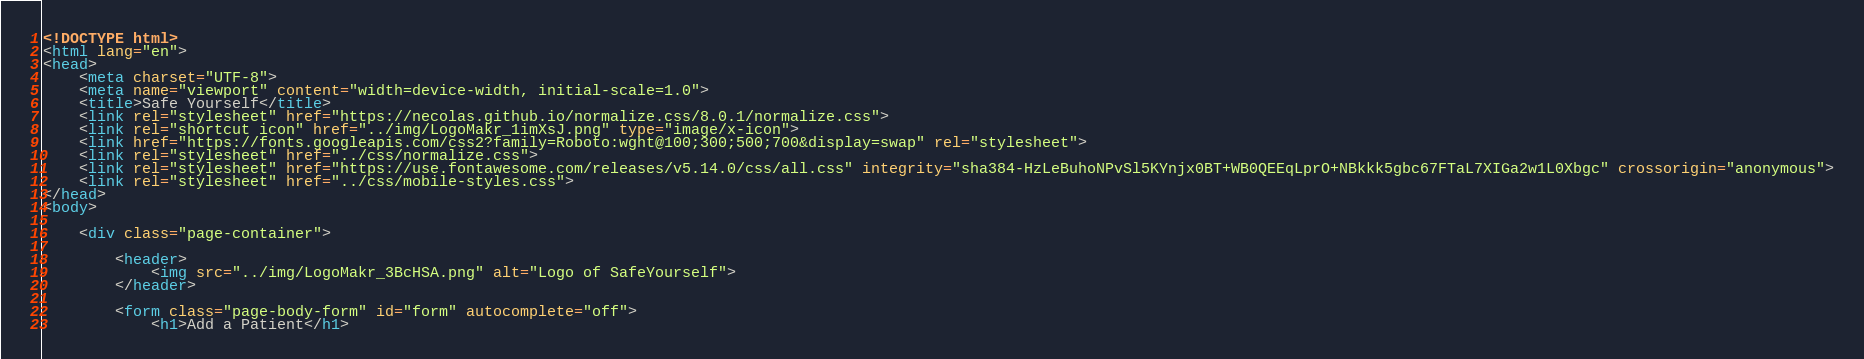Convert code to text. <code><loc_0><loc_0><loc_500><loc_500><_HTML_><!DOCTYPE html>
<html lang="en">
<head>
    <meta charset="UTF-8">
    <meta name="viewport" content="width=device-width, initial-scale=1.0">
    <title>Safe Yourself</title>
    <link rel="stylesheet" href="https://necolas.github.io/normalize.css/8.0.1/normalize.css">
    <link rel="shortcut icon" href="../img/LogoMakr_1imXsJ.png" type="image/x-icon">
    <link href="https://fonts.googleapis.com/css2?family=Roboto:wght@100;300;500;700&display=swap" rel="stylesheet">
    <link rel="stylesheet" href="../css/normalize.css">        
    <link rel="stylesheet" href="https://use.fontawesome.com/releases/v5.14.0/css/all.css" integrity="sha384-HzLeBuhoNPvSl5KYnjx0BT+WB0QEEqLprO+NBkkk5gbc67FTaL7XIGa2w1L0Xbgc" crossorigin="anonymous">
    <link rel="stylesheet" href="../css/mobile-styles.css">
</head>
<body>

    <div class="page-container">

        <header>
            <img src="../img/LogoMakr_3BcHSA.png" alt="Logo of SafeYourself">
        </header>

        <form class="page-body-form" id="form" autocomplete="off">
            <h1>Add a Patient</h1></code> 